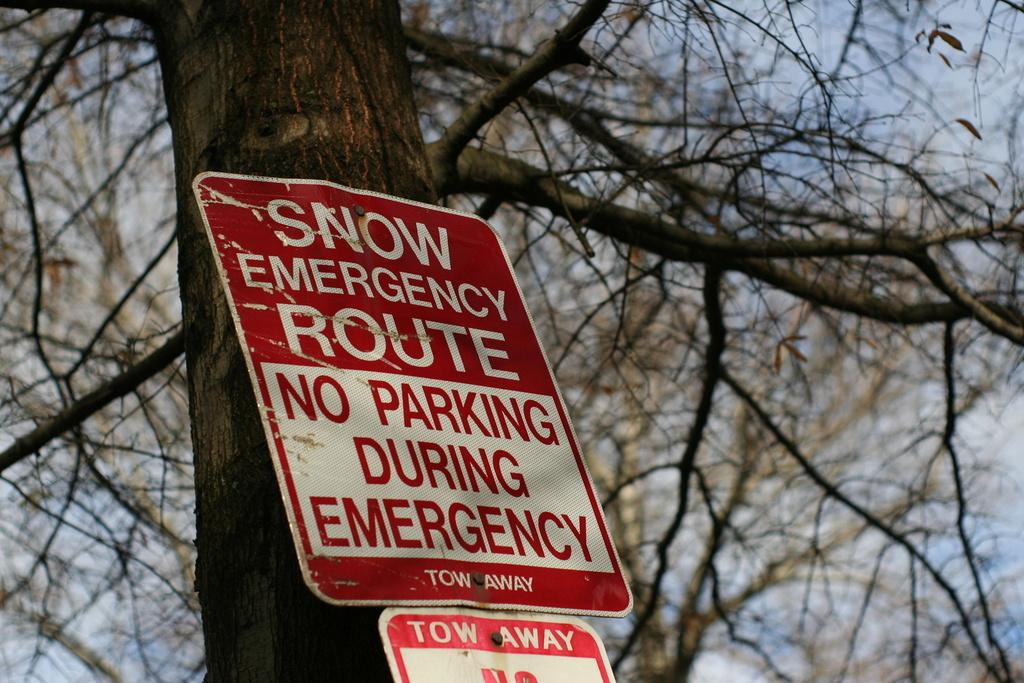What is located in the center of the image? There is a sign board in the center of the image. What does the sign board indicate or point to? The sign board points to a tree. What can be seen in the background of the image? There is a sky visible in the background of the image. What is the size of the flag on the tree in the image? There is no flag present on the tree in the image. What type of plants are growing near the sign board? The provided facts do not mention any specific plants near the sign board. 